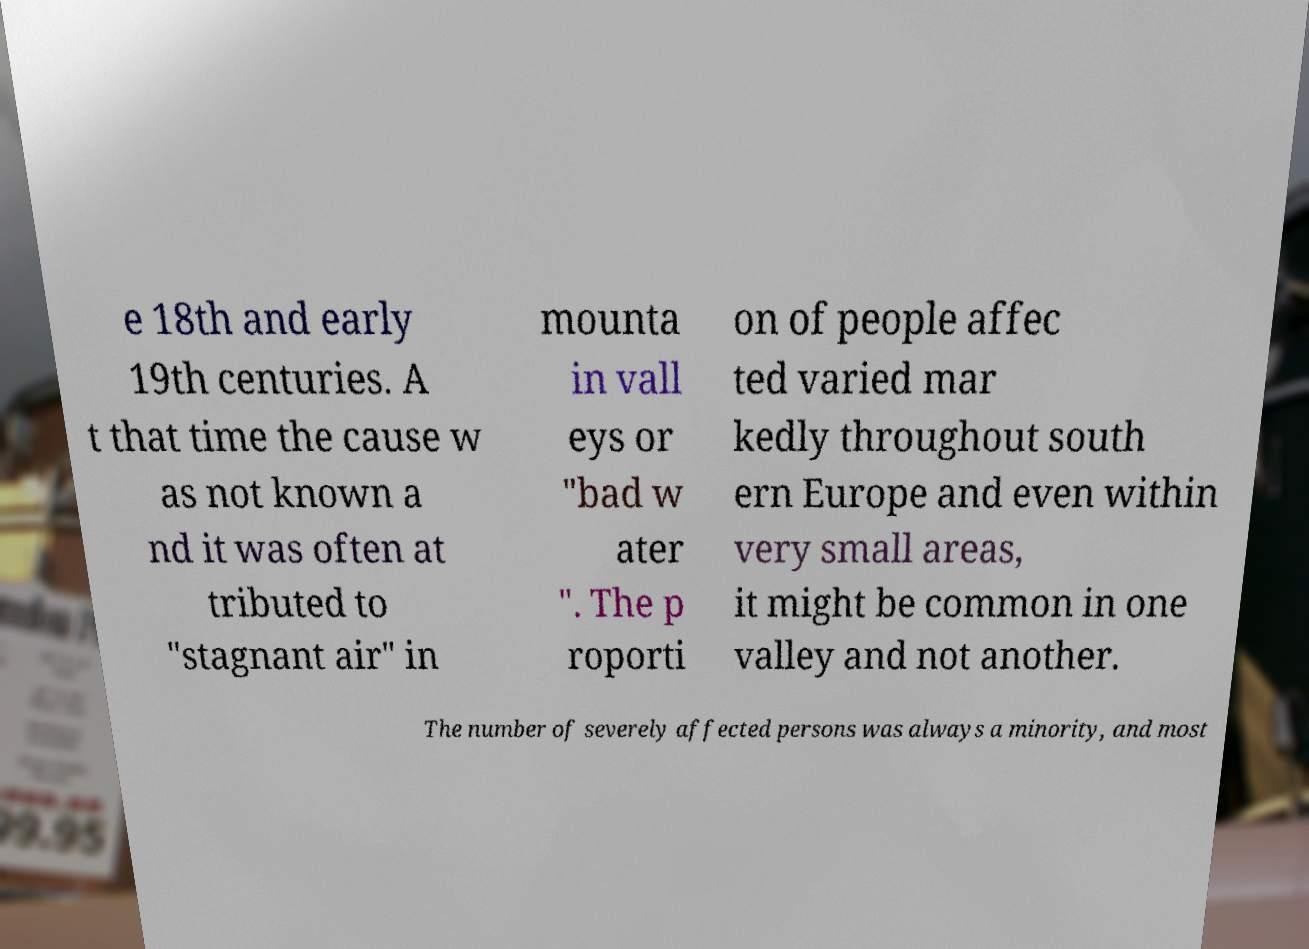Can you read and provide the text displayed in the image?This photo seems to have some interesting text. Can you extract and type it out for me? e 18th and early 19th centuries. A t that time the cause w as not known a nd it was often at tributed to "stagnant air" in mounta in vall eys or "bad w ater ". The p roporti on of people affec ted varied mar kedly throughout south ern Europe and even within very small areas, it might be common in one valley and not another. The number of severely affected persons was always a minority, and most 